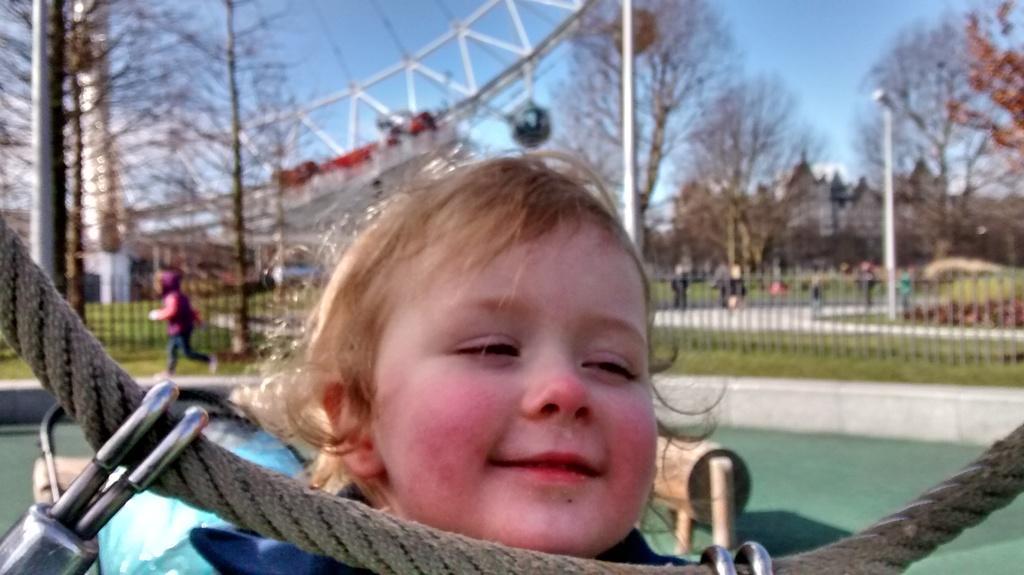Could you give a brief overview of what you see in this image? This is an outside view. Here I can see a baby smiling by looking at the right side. In front of the baby there is a rope to which two metal objects are attached. In the background there is a railing. On the left side there is a person running. In the background there are many trees, light poles and few people on the ground. On the left side there is a bridge. At the top of the image I can see the sky. 